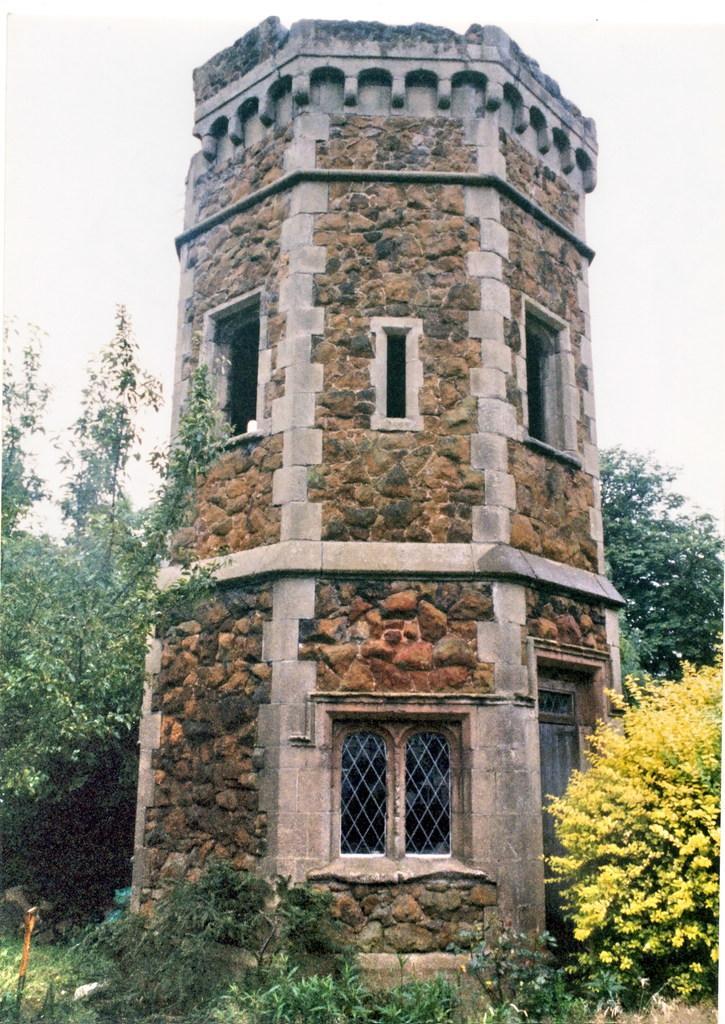Could you give a brief overview of what you see in this image? In the center of the image, we can see a fort with windows and in the background, there are trees, plants and we can see a rod. At the top, there is sky. 